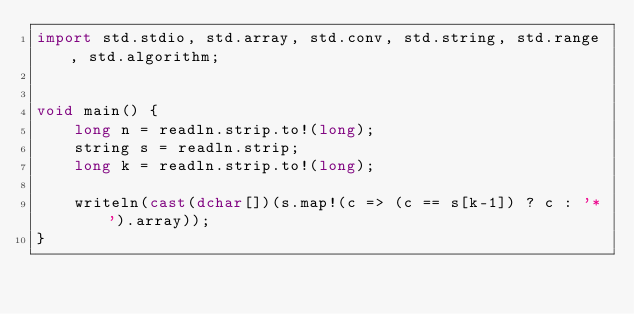Convert code to text. <code><loc_0><loc_0><loc_500><loc_500><_D_>import std.stdio, std.array, std.conv, std.string, std.range, std.algorithm;


void main() {
    long n = readln.strip.to!(long);
    string s = readln.strip;
    long k = readln.strip.to!(long);

    writeln(cast(dchar[])(s.map!(c => (c == s[k-1]) ? c : '*').array));
}
</code> 